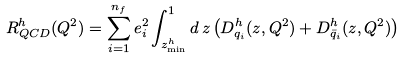Convert formula to latex. <formula><loc_0><loc_0><loc_500><loc_500>R _ { Q C D } ^ { h } ( Q ^ { 2 } ) = \sum _ { i = 1 } ^ { n _ { f } } e _ { i } ^ { 2 } \int _ { z _ { \min } ^ { h } } ^ { 1 } d \, z \left ( D _ { q _ { i } } ^ { h } ( z , Q ^ { 2 } ) + D _ { \bar { q } _ { i } } ^ { h } ( z , Q ^ { 2 } ) \right )</formula> 